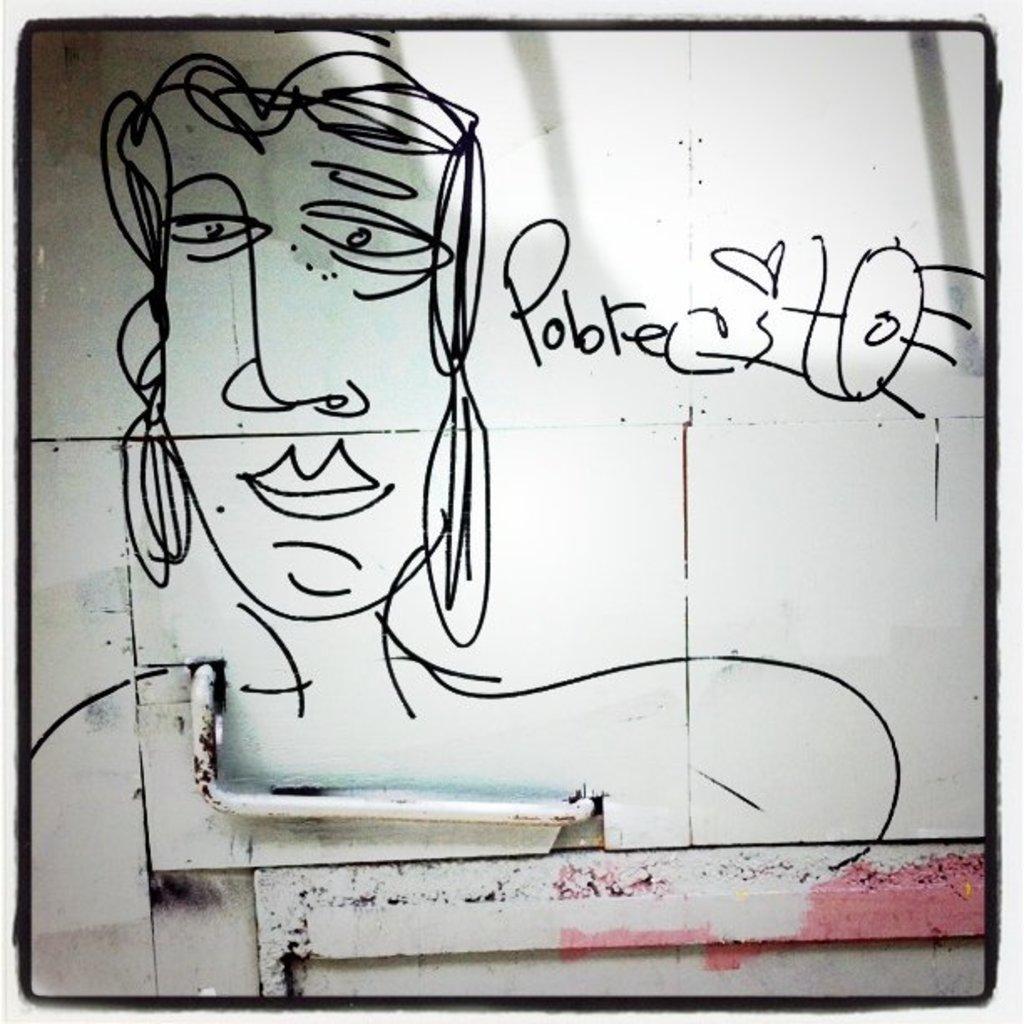Can you describe this image briefly? In this image there is a wall with an art and a text on it and there is a pipe. 